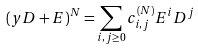Convert formula to latex. <formula><loc_0><loc_0><loc_500><loc_500>( y D + E ) ^ { N } = \sum _ { i , j \geq 0 } c ^ { ( N ) } _ { i , j } E ^ { i } D ^ { j }</formula> 